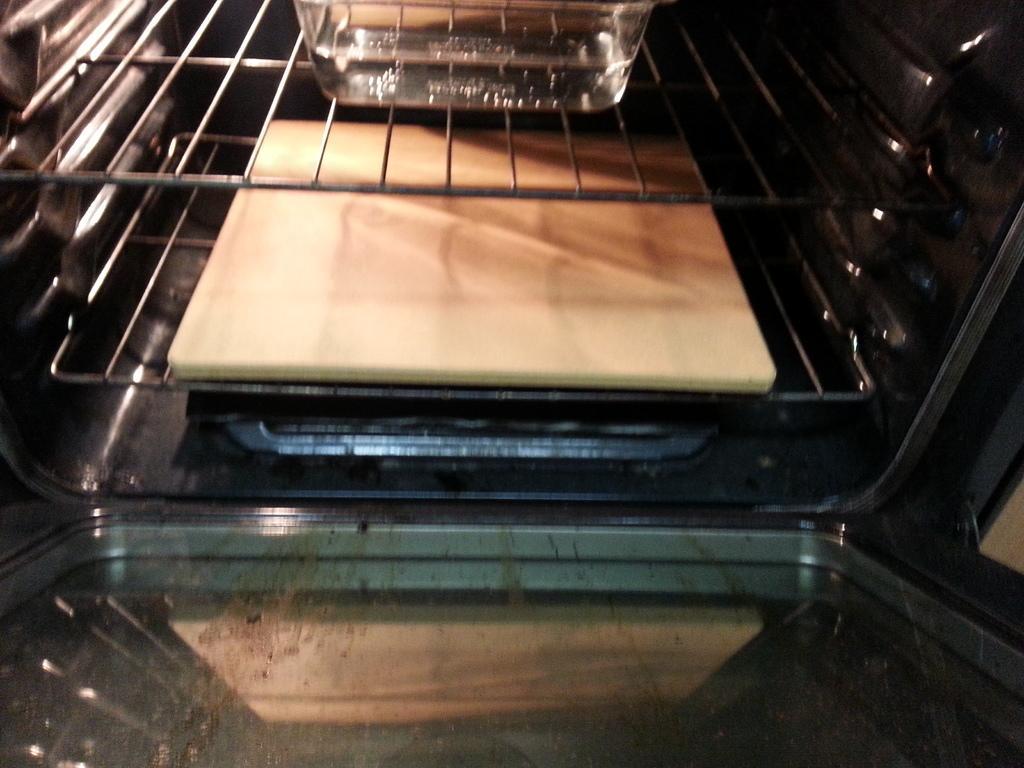Describe this image in one or two sentences. In this image I can see few trays in the box. I can see a white color plate and glass bowl on the tray. 